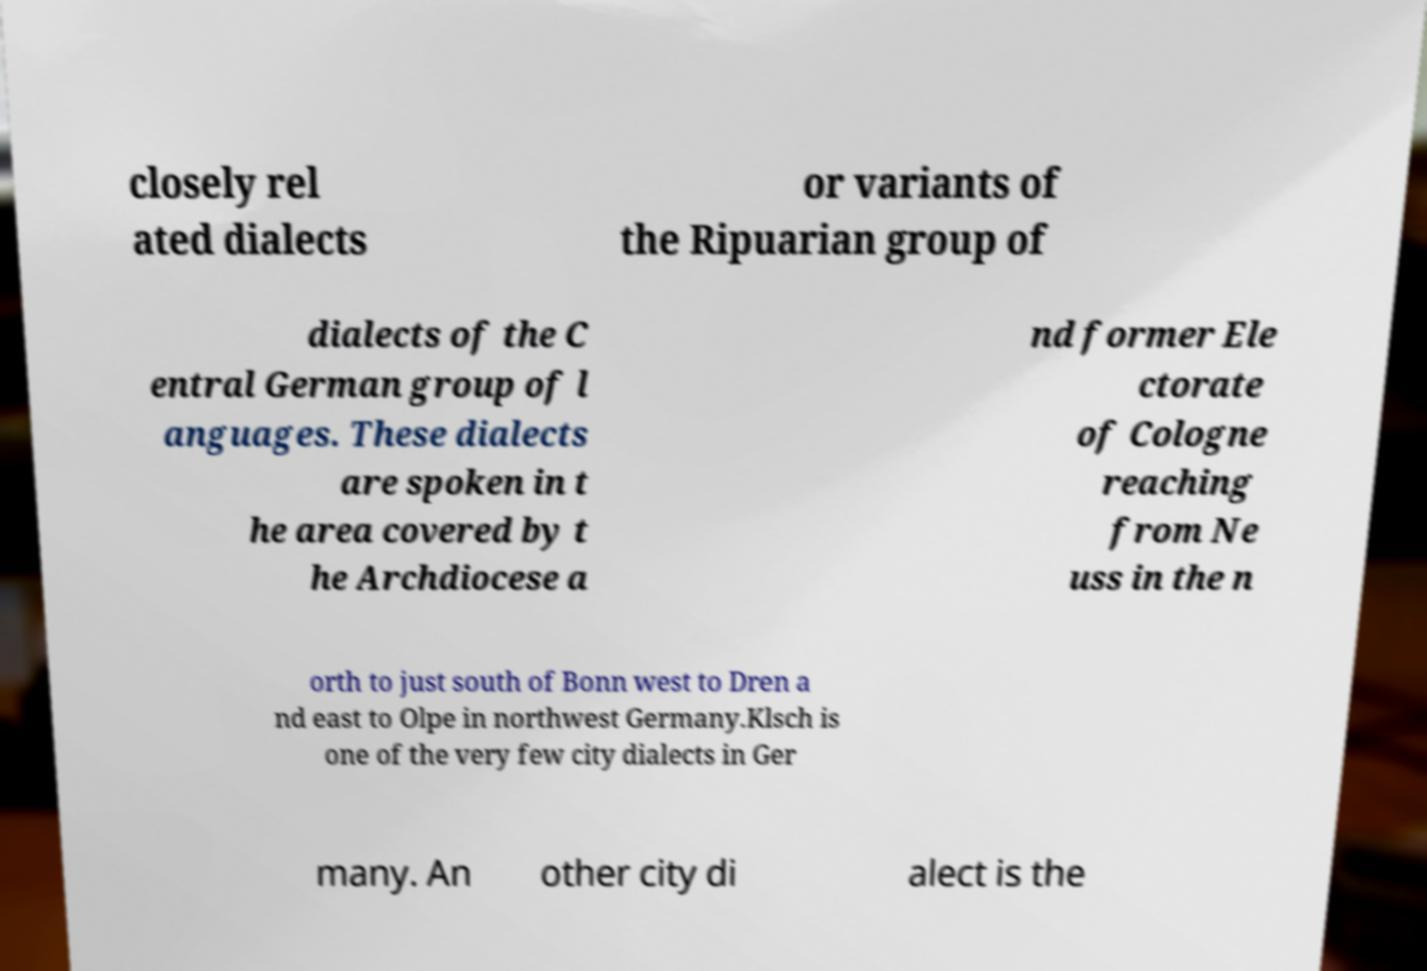Can you accurately transcribe the text from the provided image for me? closely rel ated dialects or variants of the Ripuarian group of dialects of the C entral German group of l anguages. These dialects are spoken in t he area covered by t he Archdiocese a nd former Ele ctorate of Cologne reaching from Ne uss in the n orth to just south of Bonn west to Dren a nd east to Olpe in northwest Germany.Klsch is one of the very few city dialects in Ger many. An other city di alect is the 